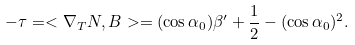<formula> <loc_0><loc_0><loc_500><loc_500>- \tau = < \nabla _ { T } N , B > = ( \cos \alpha _ { 0 } ) \beta ^ { \prime } + \frac { 1 } { 2 } - ( \cos \alpha _ { 0 } ) ^ { 2 } .</formula> 